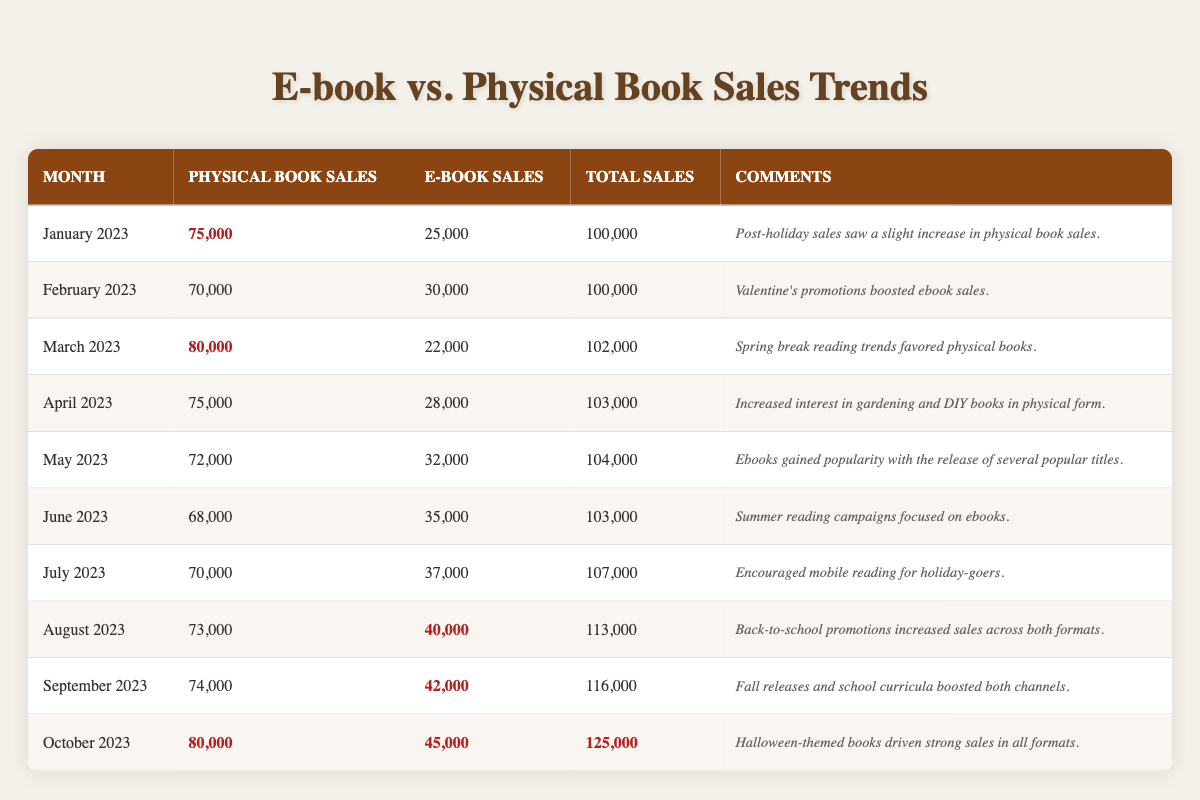What were the physical book sales in October 2023? In the row for October 2023, the value in the "Physical Book Sales" column is highlighted as 80,000.
Answer: 80,000 Which month had the highest e-book sales? By checking the "E-book Sales" column, I can see that the highest value is 45,000 for October 2023.
Answer: October 2023 What was the total sales figure in August 2023? In the row for August 2023, the total sales amount is listed as 113,000 in the "Total Sales" column.
Answer: 113,000 Did physical book sales increase in September 2023 compared to August 2023? Physical book sales in August 2023 were 73,000, and in September 2023, they were 74,000. Since 74,000 is greater than 73,000, physical book sales did increase.
Answer: Yes Calculate the average e-book sales over the last year. I will sum the e-book sales values (25,000 + 30,000 + 22,000 + 28,000 + 32,000 + 35,000 + 37,000 + 40,000 + 42,000 + 45,000) which equals  364,000. Dividing this sum by 10 (the number of months) gives an average of 36,400.
Answer: 36,400 Was there a month where physical book sales were lower than e-book sales? In February 2023, physical book sales were 70,000, while e-book sales were 30,000. Since physical sales were higher, there was no month where physical sales were lower than e-book sales.
Answer: No What was the difference in total sales between March 2023 and June 2023? Total sales in March 2023 were 102,000, and in June 2023, they were 103,000. The difference is 103,000 - 102,000 = 1,000.
Answer: 1,000 Which month had the lowest e-book sales, and what was the figure? By checking the "E-book Sales" column, the lowest value appears to be 22,000 in March 2023, which can be confirmed by comparing values in the column.
Answer: March 2023, 22,000 Was there a month where both physical and e-book sales increased compared to the previous month? From the table, comparing the sales, both physical and e-book sales in August 2023 (73,000 and 40,000) were higher than July 2023 (70,000 and 37,000), confirming the condition of both increasing.
Answer: Yes What percentage of total sales were generated from e-book sales in October 2023? In October 2023, the total sales were 125,000, and e-book sales were 45,000. The percentage is calculated as (45,000 / 125,000) * 100 = 36%.
Answer: 36% 